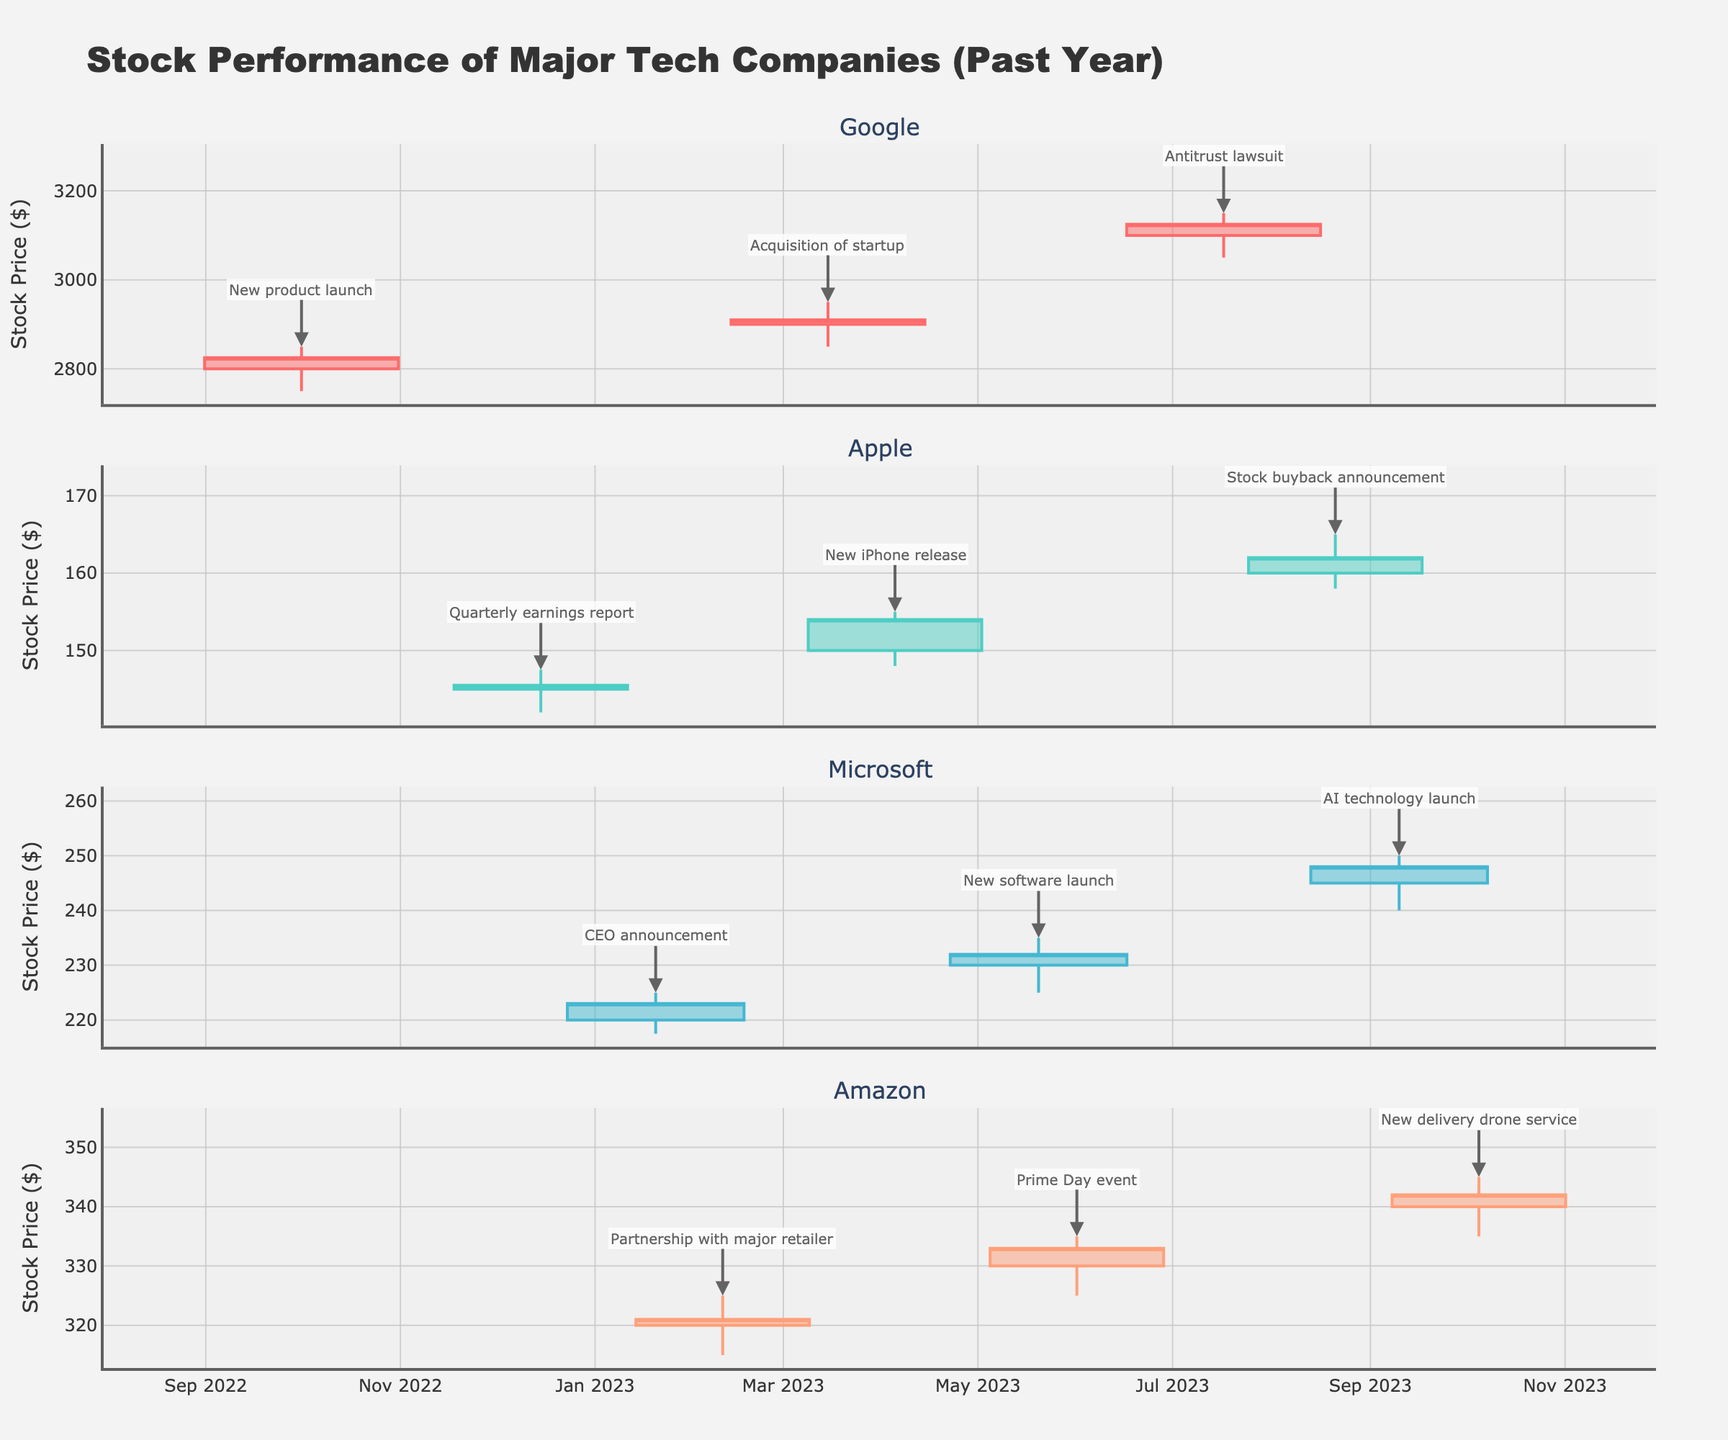What event corresponds to the highest stock price for Google? The highest stock price for Google in the figure is around March 15, 2023, with a high of 2950.00. Referring to the annotations, this date corresponds to the event "Acquisition of startup."
Answer: Acquisition of startup Which company had the highest closing stock price, and what was that value? Google had the highest closing stock price among all companies, with the closing price reaching 3125.00 on July 17, 2023.
Answer: Google, 3125.00 On which date did Apple have its lowest closing stock price, and what is the value? The figure shows that Apple had its lowest closing stock price on October 1, 2022, with a closing price of 145.50.
Answer: October 1, 2022, 145.50 How did Microsoft's stock close relative to its opening price on January 20, 2023? On January 20, 2023, Microsoft's closing price was 223.00, which is higher than its opening price of 220.00, indicating an increase.
Answer: Higher Which event led to the highest trading volume for Apple, and what was the volume? The highest trading volume for Apple occurred on April 5, 2023, during the "New iPhone release" event, with the volume reaching 12,000,000.
Answer: New iPhone release, 12,000,000 What is the average closing price for Amazon across the provided dates? The closing prices for Amazon are 321.00, 333.00, and 342.00. The average is calculated as (321.00 + 333.00 + 342.00) / 3 = 332.00.
Answer: 332.00 Compare Google's closing price on March 15, 2023, and July 17, 2023. Which day had the higher closing price and by how much? Google closed at 2910.00 on March 15, 2023, and at 3125.00 on July 17, 2023. The difference is 3125.00 - 2910.00 = 215.00, with July 17 having the higher closing price.
Answer: July 17, by 215.00 What key event is mentioned for Microsoft on September 10, 2023, and what was the closing stock price? On September 10, 2023, the key event mentioned for Microsoft is the "AI technology launch," with the closing stock price being 248.00.
Answer: AI technology launch, 248.00 During which event did Google's stock experience a notable decrease compared to the opening price? The figure shows that during the "Antitrust lawsuit" event on July 17, 2023, Google's stock experienced a notable decrease compared to the opening price, closing lower than it opened.
Answer: Antitrust lawsuit 